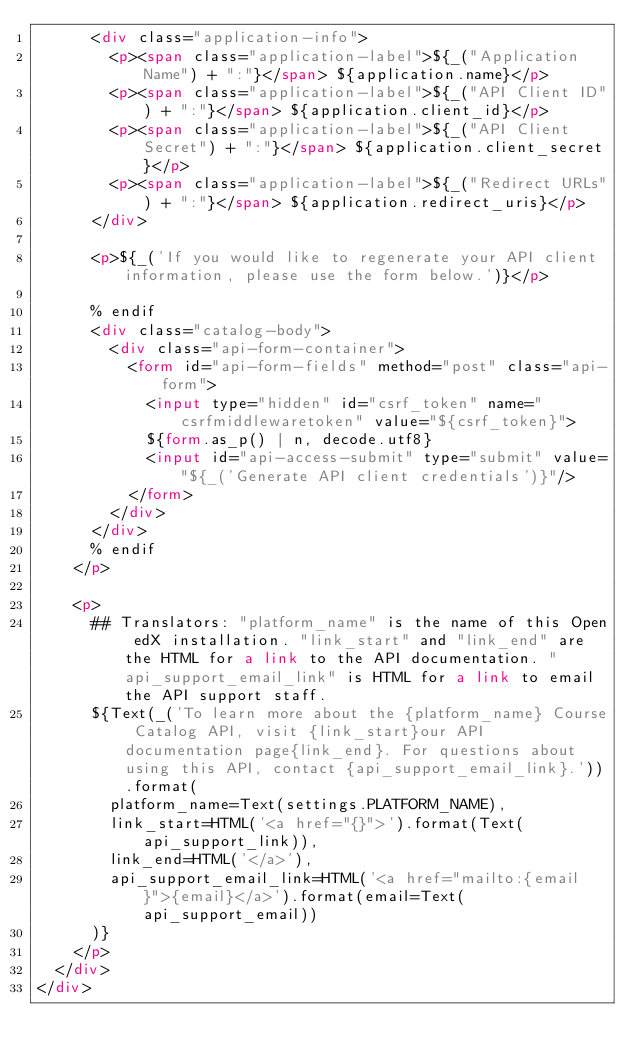Convert code to text. <code><loc_0><loc_0><loc_500><loc_500><_HTML_>      <div class="application-info">
        <p><span class="application-label">${_("Application Name") + ":"}</span> ${application.name}</p>
        <p><span class="application-label">${_("API Client ID") + ":"}</span> ${application.client_id}</p>
        <p><span class="application-label">${_("API Client Secret") + ":"}</span> ${application.client_secret}</p>
        <p><span class="application-label">${_("Redirect URLs") + ":"}</span> ${application.redirect_uris}</p>
      </div>

      <p>${_('If you would like to regenerate your API client information, please use the form below.')}</p>
      
      % endif
      <div class="catalog-body">
        <div class="api-form-container">
          <form id="api-form-fields" method="post" class="api-form">
            <input type="hidden" id="csrf_token" name="csrfmiddlewaretoken" value="${csrf_token}">
            ${form.as_p() | n, decode.utf8}
            <input id="api-access-submit" type="submit" value="${_('Generate API client credentials')}"/>
          </form>
        </div>
      </div>
      % endif
    </p>

    <p>
      ## Translators: "platform_name" is the name of this Open edX installation. "link_start" and "link_end" are the HTML for a link to the API documentation. "api_support_email_link" is HTML for a link to email the API support staff.
      ${Text(_('To learn more about the {platform_name} Course Catalog API, visit {link_start}our API documentation page{link_end}. For questions about using this API, contact {api_support_email_link}.')).format(
        platform_name=Text(settings.PLATFORM_NAME),
        link_start=HTML('<a href="{}">').format(Text(api_support_link)),
        link_end=HTML('</a>'),
        api_support_email_link=HTML('<a href="mailto:{email}">{email}</a>').format(email=Text(api_support_email))
      )}
    </p>
  </div>
</div>
</code> 